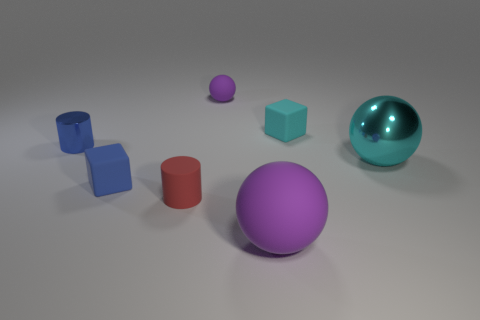Is there anything else that has the same material as the cyan sphere?
Provide a short and direct response. Yes. The ball that is in front of the tiny purple ball and left of the large cyan sphere is made of what material?
Your response must be concise. Rubber. What number of other objects are there of the same material as the large purple thing?
Keep it short and to the point. 4. How many matte things have the same color as the tiny rubber sphere?
Make the answer very short. 1. There is a blue thing that is in front of the big object that is behind the purple rubber sphere to the right of the tiny ball; how big is it?
Your answer should be compact. Small. How many metallic objects are either big green cylinders or cyan blocks?
Give a very brief answer. 0. There is a tiny red matte object; is it the same shape as the metallic object that is on the left side of the red rubber thing?
Offer a terse response. Yes. Is the number of metallic things right of the tiny red rubber thing greater than the number of rubber cylinders behind the tiny metallic cylinder?
Your answer should be very brief. Yes. Is there anything else that is the same color as the metallic cylinder?
Offer a terse response. Yes. Is there a object that is behind the block that is behind the big ball that is on the right side of the tiny cyan rubber object?
Offer a terse response. Yes. 